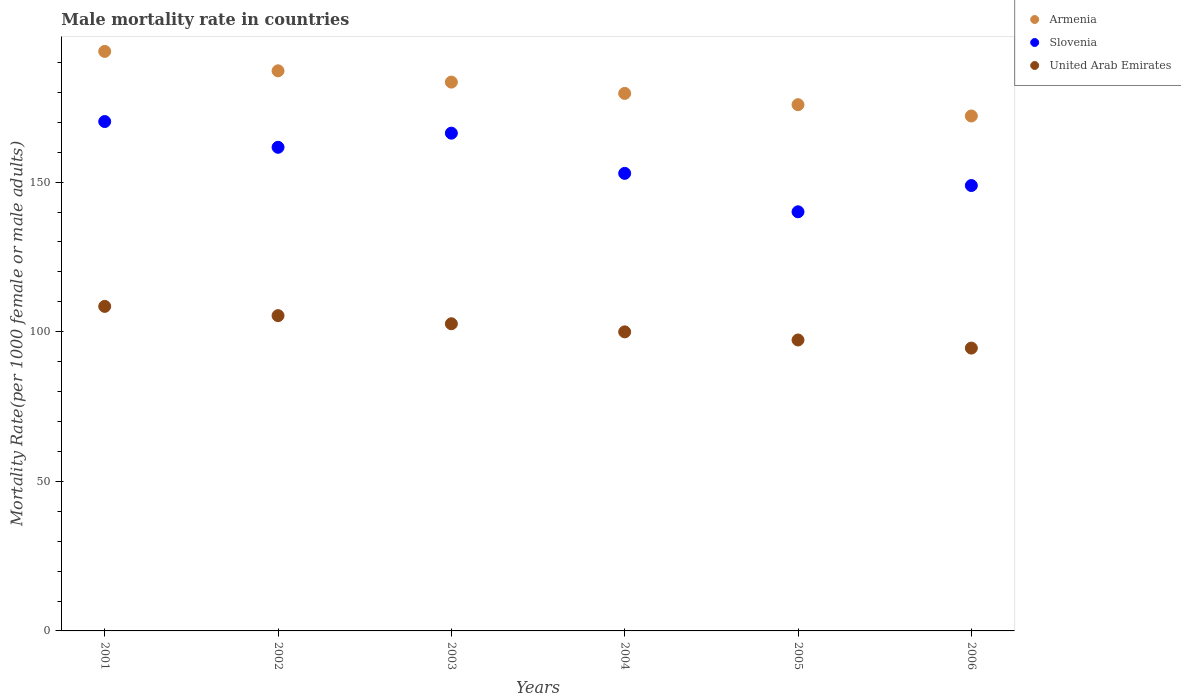How many different coloured dotlines are there?
Your answer should be compact. 3. What is the male mortality rate in Armenia in 2001?
Offer a very short reply. 193.7. Across all years, what is the maximum male mortality rate in Armenia?
Provide a succinct answer. 193.7. Across all years, what is the minimum male mortality rate in United Arab Emirates?
Your response must be concise. 94.53. In which year was the male mortality rate in United Arab Emirates maximum?
Provide a short and direct response. 2001. What is the total male mortality rate in Slovenia in the graph?
Your answer should be compact. 940.16. What is the difference between the male mortality rate in United Arab Emirates in 2002 and that in 2004?
Your answer should be compact. 5.42. What is the difference between the male mortality rate in United Arab Emirates in 2004 and the male mortality rate in Slovenia in 2002?
Your answer should be compact. -61.69. What is the average male mortality rate in Armenia per year?
Make the answer very short. 182. In the year 2005, what is the difference between the male mortality rate in Slovenia and male mortality rate in United Arab Emirates?
Your answer should be very brief. 42.84. What is the ratio of the male mortality rate in Slovenia in 2002 to that in 2003?
Give a very brief answer. 0.97. What is the difference between the highest and the second highest male mortality rate in United Arab Emirates?
Keep it short and to the point. 3.09. What is the difference between the highest and the lowest male mortality rate in Slovenia?
Keep it short and to the point. 30.17. In how many years, is the male mortality rate in Slovenia greater than the average male mortality rate in Slovenia taken over all years?
Provide a succinct answer. 3. Is the sum of the male mortality rate in Armenia in 2001 and 2005 greater than the maximum male mortality rate in United Arab Emirates across all years?
Provide a short and direct response. Yes. Is it the case that in every year, the sum of the male mortality rate in Slovenia and male mortality rate in Armenia  is greater than the male mortality rate in United Arab Emirates?
Provide a succinct answer. Yes. Does the male mortality rate in Armenia monotonically increase over the years?
Make the answer very short. No. Is the male mortality rate in Armenia strictly greater than the male mortality rate in Slovenia over the years?
Offer a very short reply. Yes. How many years are there in the graph?
Offer a very short reply. 6. What is the difference between two consecutive major ticks on the Y-axis?
Your answer should be very brief. 50. Are the values on the major ticks of Y-axis written in scientific E-notation?
Give a very brief answer. No. Does the graph contain grids?
Your answer should be compact. No. How many legend labels are there?
Your answer should be very brief. 3. What is the title of the graph?
Offer a very short reply. Male mortality rate in countries. Does "Papua New Guinea" appear as one of the legend labels in the graph?
Give a very brief answer. No. What is the label or title of the Y-axis?
Offer a very short reply. Mortality Rate(per 1000 female or male adults). What is the Mortality Rate(per 1000 female or male adults) in Armenia in 2001?
Provide a succinct answer. 193.7. What is the Mortality Rate(per 1000 female or male adults) of Slovenia in 2001?
Your answer should be very brief. 170.25. What is the Mortality Rate(per 1000 female or male adults) of United Arab Emirates in 2001?
Make the answer very short. 108.47. What is the Mortality Rate(per 1000 female or male adults) of Armenia in 2002?
Your answer should be very brief. 187.21. What is the Mortality Rate(per 1000 female or male adults) of Slovenia in 2002?
Make the answer very short. 161.65. What is the Mortality Rate(per 1000 female or male adults) of United Arab Emirates in 2002?
Your answer should be very brief. 105.38. What is the Mortality Rate(per 1000 female or male adults) of Armenia in 2003?
Provide a succinct answer. 183.43. What is the Mortality Rate(per 1000 female or male adults) in Slovenia in 2003?
Offer a very short reply. 166.37. What is the Mortality Rate(per 1000 female or male adults) of United Arab Emirates in 2003?
Ensure brevity in your answer.  102.67. What is the Mortality Rate(per 1000 female or male adults) of Armenia in 2004?
Ensure brevity in your answer.  179.66. What is the Mortality Rate(per 1000 female or male adults) of Slovenia in 2004?
Provide a short and direct response. 152.93. What is the Mortality Rate(per 1000 female or male adults) of United Arab Emirates in 2004?
Offer a terse response. 99.96. What is the Mortality Rate(per 1000 female or male adults) in Armenia in 2005?
Give a very brief answer. 175.89. What is the Mortality Rate(per 1000 female or male adults) of Slovenia in 2005?
Offer a terse response. 140.09. What is the Mortality Rate(per 1000 female or male adults) of United Arab Emirates in 2005?
Keep it short and to the point. 97.25. What is the Mortality Rate(per 1000 female or male adults) in Armenia in 2006?
Provide a short and direct response. 172.11. What is the Mortality Rate(per 1000 female or male adults) in Slovenia in 2006?
Ensure brevity in your answer.  148.87. What is the Mortality Rate(per 1000 female or male adults) in United Arab Emirates in 2006?
Ensure brevity in your answer.  94.53. Across all years, what is the maximum Mortality Rate(per 1000 female or male adults) of Armenia?
Offer a very short reply. 193.7. Across all years, what is the maximum Mortality Rate(per 1000 female or male adults) in Slovenia?
Offer a terse response. 170.25. Across all years, what is the maximum Mortality Rate(per 1000 female or male adults) in United Arab Emirates?
Give a very brief answer. 108.47. Across all years, what is the minimum Mortality Rate(per 1000 female or male adults) of Armenia?
Your answer should be compact. 172.11. Across all years, what is the minimum Mortality Rate(per 1000 female or male adults) of Slovenia?
Ensure brevity in your answer.  140.09. Across all years, what is the minimum Mortality Rate(per 1000 female or male adults) in United Arab Emirates?
Keep it short and to the point. 94.53. What is the total Mortality Rate(per 1000 female or male adults) in Armenia in the graph?
Offer a terse response. 1092. What is the total Mortality Rate(per 1000 female or male adults) in Slovenia in the graph?
Make the answer very short. 940.16. What is the total Mortality Rate(per 1000 female or male adults) in United Arab Emirates in the graph?
Provide a short and direct response. 608.25. What is the difference between the Mortality Rate(per 1000 female or male adults) in Armenia in 2001 and that in 2002?
Offer a very short reply. 6.49. What is the difference between the Mortality Rate(per 1000 female or male adults) of Slovenia in 2001 and that in 2002?
Ensure brevity in your answer.  8.6. What is the difference between the Mortality Rate(per 1000 female or male adults) in United Arab Emirates in 2001 and that in 2002?
Provide a succinct answer. 3.1. What is the difference between the Mortality Rate(per 1000 female or male adults) of Armenia in 2001 and that in 2003?
Give a very brief answer. 10.26. What is the difference between the Mortality Rate(per 1000 female or male adults) of Slovenia in 2001 and that in 2003?
Offer a very short reply. 3.88. What is the difference between the Mortality Rate(per 1000 female or male adults) of United Arab Emirates in 2001 and that in 2003?
Offer a very short reply. 5.81. What is the difference between the Mortality Rate(per 1000 female or male adults) of Armenia in 2001 and that in 2004?
Offer a very short reply. 14.04. What is the difference between the Mortality Rate(per 1000 female or male adults) of Slovenia in 2001 and that in 2004?
Your answer should be very brief. 17.32. What is the difference between the Mortality Rate(per 1000 female or male adults) in United Arab Emirates in 2001 and that in 2004?
Ensure brevity in your answer.  8.52. What is the difference between the Mortality Rate(per 1000 female or male adults) in Armenia in 2001 and that in 2005?
Make the answer very short. 17.81. What is the difference between the Mortality Rate(per 1000 female or male adults) of Slovenia in 2001 and that in 2005?
Make the answer very short. 30.17. What is the difference between the Mortality Rate(per 1000 female or male adults) of United Arab Emirates in 2001 and that in 2005?
Provide a succinct answer. 11.23. What is the difference between the Mortality Rate(per 1000 female or male adults) in Armenia in 2001 and that in 2006?
Your answer should be very brief. 21.58. What is the difference between the Mortality Rate(per 1000 female or male adults) in Slovenia in 2001 and that in 2006?
Offer a terse response. 21.38. What is the difference between the Mortality Rate(per 1000 female or male adults) in United Arab Emirates in 2001 and that in 2006?
Provide a succinct answer. 13.94. What is the difference between the Mortality Rate(per 1000 female or male adults) of Armenia in 2002 and that in 2003?
Offer a terse response. 3.77. What is the difference between the Mortality Rate(per 1000 female or male adults) in Slovenia in 2002 and that in 2003?
Your answer should be compact. -4.72. What is the difference between the Mortality Rate(per 1000 female or male adults) of United Arab Emirates in 2002 and that in 2003?
Give a very brief answer. 2.71. What is the difference between the Mortality Rate(per 1000 female or male adults) in Armenia in 2002 and that in 2004?
Keep it short and to the point. 7.55. What is the difference between the Mortality Rate(per 1000 female or male adults) in Slovenia in 2002 and that in 2004?
Offer a very short reply. 8.72. What is the difference between the Mortality Rate(per 1000 female or male adults) of United Arab Emirates in 2002 and that in 2004?
Provide a succinct answer. 5.42. What is the difference between the Mortality Rate(per 1000 female or male adults) of Armenia in 2002 and that in 2005?
Your answer should be compact. 11.32. What is the difference between the Mortality Rate(per 1000 female or male adults) in Slovenia in 2002 and that in 2005?
Give a very brief answer. 21.56. What is the difference between the Mortality Rate(per 1000 female or male adults) in United Arab Emirates in 2002 and that in 2005?
Offer a terse response. 8.13. What is the difference between the Mortality Rate(per 1000 female or male adults) of Armenia in 2002 and that in 2006?
Your answer should be very brief. 15.09. What is the difference between the Mortality Rate(per 1000 female or male adults) of Slovenia in 2002 and that in 2006?
Provide a short and direct response. 12.78. What is the difference between the Mortality Rate(per 1000 female or male adults) of United Arab Emirates in 2002 and that in 2006?
Offer a terse response. 10.84. What is the difference between the Mortality Rate(per 1000 female or male adults) in Armenia in 2003 and that in 2004?
Your answer should be compact. 3.77. What is the difference between the Mortality Rate(per 1000 female or male adults) of Slovenia in 2003 and that in 2004?
Keep it short and to the point. 13.44. What is the difference between the Mortality Rate(per 1000 female or male adults) in United Arab Emirates in 2003 and that in 2004?
Provide a short and direct response. 2.71. What is the difference between the Mortality Rate(per 1000 female or male adults) in Armenia in 2003 and that in 2005?
Offer a very short reply. 7.55. What is the difference between the Mortality Rate(per 1000 female or male adults) in Slovenia in 2003 and that in 2005?
Your answer should be very brief. 26.29. What is the difference between the Mortality Rate(per 1000 female or male adults) in United Arab Emirates in 2003 and that in 2005?
Your answer should be very brief. 5.42. What is the difference between the Mortality Rate(per 1000 female or male adults) in Armenia in 2003 and that in 2006?
Make the answer very short. 11.32. What is the difference between the Mortality Rate(per 1000 female or male adults) in United Arab Emirates in 2003 and that in 2006?
Your answer should be compact. 8.13. What is the difference between the Mortality Rate(per 1000 female or male adults) in Armenia in 2004 and that in 2005?
Your answer should be compact. 3.77. What is the difference between the Mortality Rate(per 1000 female or male adults) of Slovenia in 2004 and that in 2005?
Make the answer very short. 12.85. What is the difference between the Mortality Rate(per 1000 female or male adults) of United Arab Emirates in 2004 and that in 2005?
Give a very brief answer. 2.71. What is the difference between the Mortality Rate(per 1000 female or male adults) in Armenia in 2004 and that in 2006?
Ensure brevity in your answer.  7.55. What is the difference between the Mortality Rate(per 1000 female or male adults) of Slovenia in 2004 and that in 2006?
Provide a short and direct response. 4.06. What is the difference between the Mortality Rate(per 1000 female or male adults) in United Arab Emirates in 2004 and that in 2006?
Your response must be concise. 5.42. What is the difference between the Mortality Rate(per 1000 female or male adults) of Armenia in 2005 and that in 2006?
Give a very brief answer. 3.77. What is the difference between the Mortality Rate(per 1000 female or male adults) in Slovenia in 2005 and that in 2006?
Provide a succinct answer. -8.79. What is the difference between the Mortality Rate(per 1000 female or male adults) of United Arab Emirates in 2005 and that in 2006?
Give a very brief answer. 2.71. What is the difference between the Mortality Rate(per 1000 female or male adults) of Armenia in 2001 and the Mortality Rate(per 1000 female or male adults) of Slovenia in 2002?
Your answer should be very brief. 32.05. What is the difference between the Mortality Rate(per 1000 female or male adults) in Armenia in 2001 and the Mortality Rate(per 1000 female or male adults) in United Arab Emirates in 2002?
Provide a short and direct response. 88.32. What is the difference between the Mortality Rate(per 1000 female or male adults) of Slovenia in 2001 and the Mortality Rate(per 1000 female or male adults) of United Arab Emirates in 2002?
Provide a short and direct response. 64.88. What is the difference between the Mortality Rate(per 1000 female or male adults) of Armenia in 2001 and the Mortality Rate(per 1000 female or male adults) of Slovenia in 2003?
Make the answer very short. 27.32. What is the difference between the Mortality Rate(per 1000 female or male adults) in Armenia in 2001 and the Mortality Rate(per 1000 female or male adults) in United Arab Emirates in 2003?
Your answer should be compact. 91.03. What is the difference between the Mortality Rate(per 1000 female or male adults) in Slovenia in 2001 and the Mortality Rate(per 1000 female or male adults) in United Arab Emirates in 2003?
Give a very brief answer. 67.59. What is the difference between the Mortality Rate(per 1000 female or male adults) in Armenia in 2001 and the Mortality Rate(per 1000 female or male adults) in Slovenia in 2004?
Offer a very short reply. 40.76. What is the difference between the Mortality Rate(per 1000 female or male adults) of Armenia in 2001 and the Mortality Rate(per 1000 female or male adults) of United Arab Emirates in 2004?
Keep it short and to the point. 93.74. What is the difference between the Mortality Rate(per 1000 female or male adults) in Slovenia in 2001 and the Mortality Rate(per 1000 female or male adults) in United Arab Emirates in 2004?
Make the answer very short. 70.3. What is the difference between the Mortality Rate(per 1000 female or male adults) in Armenia in 2001 and the Mortality Rate(per 1000 female or male adults) in Slovenia in 2005?
Make the answer very short. 53.61. What is the difference between the Mortality Rate(per 1000 female or male adults) of Armenia in 2001 and the Mortality Rate(per 1000 female or male adults) of United Arab Emirates in 2005?
Ensure brevity in your answer.  96.45. What is the difference between the Mortality Rate(per 1000 female or male adults) of Slovenia in 2001 and the Mortality Rate(per 1000 female or male adults) of United Arab Emirates in 2005?
Keep it short and to the point. 73.01. What is the difference between the Mortality Rate(per 1000 female or male adults) in Armenia in 2001 and the Mortality Rate(per 1000 female or male adults) in Slovenia in 2006?
Offer a very short reply. 44.83. What is the difference between the Mortality Rate(per 1000 female or male adults) of Armenia in 2001 and the Mortality Rate(per 1000 female or male adults) of United Arab Emirates in 2006?
Provide a short and direct response. 99.16. What is the difference between the Mortality Rate(per 1000 female or male adults) of Slovenia in 2001 and the Mortality Rate(per 1000 female or male adults) of United Arab Emirates in 2006?
Your answer should be compact. 75.72. What is the difference between the Mortality Rate(per 1000 female or male adults) in Armenia in 2002 and the Mortality Rate(per 1000 female or male adults) in Slovenia in 2003?
Provide a short and direct response. 20.84. What is the difference between the Mortality Rate(per 1000 female or male adults) in Armenia in 2002 and the Mortality Rate(per 1000 female or male adults) in United Arab Emirates in 2003?
Your answer should be very brief. 84.54. What is the difference between the Mortality Rate(per 1000 female or male adults) of Slovenia in 2002 and the Mortality Rate(per 1000 female or male adults) of United Arab Emirates in 2003?
Your answer should be very brief. 58.98. What is the difference between the Mortality Rate(per 1000 female or male adults) in Armenia in 2002 and the Mortality Rate(per 1000 female or male adults) in Slovenia in 2004?
Offer a very short reply. 34.27. What is the difference between the Mortality Rate(per 1000 female or male adults) in Armenia in 2002 and the Mortality Rate(per 1000 female or male adults) in United Arab Emirates in 2004?
Offer a very short reply. 87.25. What is the difference between the Mortality Rate(per 1000 female or male adults) of Slovenia in 2002 and the Mortality Rate(per 1000 female or male adults) of United Arab Emirates in 2004?
Ensure brevity in your answer.  61.69. What is the difference between the Mortality Rate(per 1000 female or male adults) of Armenia in 2002 and the Mortality Rate(per 1000 female or male adults) of Slovenia in 2005?
Give a very brief answer. 47.12. What is the difference between the Mortality Rate(per 1000 female or male adults) in Armenia in 2002 and the Mortality Rate(per 1000 female or male adults) in United Arab Emirates in 2005?
Keep it short and to the point. 89.96. What is the difference between the Mortality Rate(per 1000 female or male adults) in Slovenia in 2002 and the Mortality Rate(per 1000 female or male adults) in United Arab Emirates in 2005?
Your answer should be compact. 64.41. What is the difference between the Mortality Rate(per 1000 female or male adults) in Armenia in 2002 and the Mortality Rate(per 1000 female or male adults) in Slovenia in 2006?
Make the answer very short. 38.34. What is the difference between the Mortality Rate(per 1000 female or male adults) of Armenia in 2002 and the Mortality Rate(per 1000 female or male adults) of United Arab Emirates in 2006?
Your answer should be very brief. 92.67. What is the difference between the Mortality Rate(per 1000 female or male adults) of Slovenia in 2002 and the Mortality Rate(per 1000 female or male adults) of United Arab Emirates in 2006?
Your response must be concise. 67.12. What is the difference between the Mortality Rate(per 1000 female or male adults) in Armenia in 2003 and the Mortality Rate(per 1000 female or male adults) in Slovenia in 2004?
Offer a terse response. 30.5. What is the difference between the Mortality Rate(per 1000 female or male adults) in Armenia in 2003 and the Mortality Rate(per 1000 female or male adults) in United Arab Emirates in 2004?
Make the answer very short. 83.48. What is the difference between the Mortality Rate(per 1000 female or male adults) of Slovenia in 2003 and the Mortality Rate(per 1000 female or male adults) of United Arab Emirates in 2004?
Ensure brevity in your answer.  66.42. What is the difference between the Mortality Rate(per 1000 female or male adults) in Armenia in 2003 and the Mortality Rate(per 1000 female or male adults) in Slovenia in 2005?
Offer a very short reply. 43.35. What is the difference between the Mortality Rate(per 1000 female or male adults) in Armenia in 2003 and the Mortality Rate(per 1000 female or male adults) in United Arab Emirates in 2005?
Make the answer very short. 86.19. What is the difference between the Mortality Rate(per 1000 female or male adults) in Slovenia in 2003 and the Mortality Rate(per 1000 female or male adults) in United Arab Emirates in 2005?
Ensure brevity in your answer.  69.13. What is the difference between the Mortality Rate(per 1000 female or male adults) of Armenia in 2003 and the Mortality Rate(per 1000 female or male adults) of Slovenia in 2006?
Provide a short and direct response. 34.56. What is the difference between the Mortality Rate(per 1000 female or male adults) of Armenia in 2003 and the Mortality Rate(per 1000 female or male adults) of United Arab Emirates in 2006?
Offer a terse response. 88.9. What is the difference between the Mortality Rate(per 1000 female or male adults) in Slovenia in 2003 and the Mortality Rate(per 1000 female or male adults) in United Arab Emirates in 2006?
Give a very brief answer. 71.84. What is the difference between the Mortality Rate(per 1000 female or male adults) of Armenia in 2004 and the Mortality Rate(per 1000 female or male adults) of Slovenia in 2005?
Ensure brevity in your answer.  39.57. What is the difference between the Mortality Rate(per 1000 female or male adults) of Armenia in 2004 and the Mortality Rate(per 1000 female or male adults) of United Arab Emirates in 2005?
Provide a short and direct response. 82.42. What is the difference between the Mortality Rate(per 1000 female or male adults) in Slovenia in 2004 and the Mortality Rate(per 1000 female or male adults) in United Arab Emirates in 2005?
Your response must be concise. 55.69. What is the difference between the Mortality Rate(per 1000 female or male adults) of Armenia in 2004 and the Mortality Rate(per 1000 female or male adults) of Slovenia in 2006?
Keep it short and to the point. 30.79. What is the difference between the Mortality Rate(per 1000 female or male adults) in Armenia in 2004 and the Mortality Rate(per 1000 female or male adults) in United Arab Emirates in 2006?
Ensure brevity in your answer.  85.13. What is the difference between the Mortality Rate(per 1000 female or male adults) of Slovenia in 2004 and the Mortality Rate(per 1000 female or male adults) of United Arab Emirates in 2006?
Make the answer very short. 58.4. What is the difference between the Mortality Rate(per 1000 female or male adults) in Armenia in 2005 and the Mortality Rate(per 1000 female or male adults) in Slovenia in 2006?
Your response must be concise. 27.02. What is the difference between the Mortality Rate(per 1000 female or male adults) in Armenia in 2005 and the Mortality Rate(per 1000 female or male adults) in United Arab Emirates in 2006?
Provide a short and direct response. 81.35. What is the difference between the Mortality Rate(per 1000 female or male adults) of Slovenia in 2005 and the Mortality Rate(per 1000 female or male adults) of United Arab Emirates in 2006?
Provide a short and direct response. 45.55. What is the average Mortality Rate(per 1000 female or male adults) of Armenia per year?
Provide a succinct answer. 182. What is the average Mortality Rate(per 1000 female or male adults) of Slovenia per year?
Your answer should be very brief. 156.69. What is the average Mortality Rate(per 1000 female or male adults) in United Arab Emirates per year?
Your answer should be very brief. 101.38. In the year 2001, what is the difference between the Mortality Rate(per 1000 female or male adults) in Armenia and Mortality Rate(per 1000 female or male adults) in Slovenia?
Offer a terse response. 23.44. In the year 2001, what is the difference between the Mortality Rate(per 1000 female or male adults) in Armenia and Mortality Rate(per 1000 female or male adults) in United Arab Emirates?
Provide a succinct answer. 85.22. In the year 2001, what is the difference between the Mortality Rate(per 1000 female or male adults) of Slovenia and Mortality Rate(per 1000 female or male adults) of United Arab Emirates?
Your answer should be compact. 61.78. In the year 2002, what is the difference between the Mortality Rate(per 1000 female or male adults) in Armenia and Mortality Rate(per 1000 female or male adults) in Slovenia?
Provide a succinct answer. 25.56. In the year 2002, what is the difference between the Mortality Rate(per 1000 female or male adults) of Armenia and Mortality Rate(per 1000 female or male adults) of United Arab Emirates?
Your answer should be compact. 81.83. In the year 2002, what is the difference between the Mortality Rate(per 1000 female or male adults) in Slovenia and Mortality Rate(per 1000 female or male adults) in United Arab Emirates?
Give a very brief answer. 56.27. In the year 2003, what is the difference between the Mortality Rate(per 1000 female or male adults) of Armenia and Mortality Rate(per 1000 female or male adults) of Slovenia?
Ensure brevity in your answer.  17.06. In the year 2003, what is the difference between the Mortality Rate(per 1000 female or male adults) of Armenia and Mortality Rate(per 1000 female or male adults) of United Arab Emirates?
Make the answer very short. 80.77. In the year 2003, what is the difference between the Mortality Rate(per 1000 female or male adults) of Slovenia and Mortality Rate(per 1000 female or male adults) of United Arab Emirates?
Keep it short and to the point. 63.7. In the year 2004, what is the difference between the Mortality Rate(per 1000 female or male adults) of Armenia and Mortality Rate(per 1000 female or male adults) of Slovenia?
Your answer should be compact. 26.73. In the year 2004, what is the difference between the Mortality Rate(per 1000 female or male adults) of Armenia and Mortality Rate(per 1000 female or male adults) of United Arab Emirates?
Ensure brevity in your answer.  79.7. In the year 2004, what is the difference between the Mortality Rate(per 1000 female or male adults) in Slovenia and Mortality Rate(per 1000 female or male adults) in United Arab Emirates?
Make the answer very short. 52.98. In the year 2005, what is the difference between the Mortality Rate(per 1000 female or male adults) in Armenia and Mortality Rate(per 1000 female or male adults) in Slovenia?
Your answer should be very brief. 35.8. In the year 2005, what is the difference between the Mortality Rate(per 1000 female or male adults) in Armenia and Mortality Rate(per 1000 female or male adults) in United Arab Emirates?
Keep it short and to the point. 78.64. In the year 2005, what is the difference between the Mortality Rate(per 1000 female or male adults) of Slovenia and Mortality Rate(per 1000 female or male adults) of United Arab Emirates?
Ensure brevity in your answer.  42.84. In the year 2006, what is the difference between the Mortality Rate(per 1000 female or male adults) in Armenia and Mortality Rate(per 1000 female or male adults) in Slovenia?
Ensure brevity in your answer.  23.24. In the year 2006, what is the difference between the Mortality Rate(per 1000 female or male adults) of Armenia and Mortality Rate(per 1000 female or male adults) of United Arab Emirates?
Give a very brief answer. 77.58. In the year 2006, what is the difference between the Mortality Rate(per 1000 female or male adults) of Slovenia and Mortality Rate(per 1000 female or male adults) of United Arab Emirates?
Offer a very short reply. 54.34. What is the ratio of the Mortality Rate(per 1000 female or male adults) in Armenia in 2001 to that in 2002?
Provide a succinct answer. 1.03. What is the ratio of the Mortality Rate(per 1000 female or male adults) in Slovenia in 2001 to that in 2002?
Ensure brevity in your answer.  1.05. What is the ratio of the Mortality Rate(per 1000 female or male adults) of United Arab Emirates in 2001 to that in 2002?
Provide a short and direct response. 1.03. What is the ratio of the Mortality Rate(per 1000 female or male adults) in Armenia in 2001 to that in 2003?
Offer a terse response. 1.06. What is the ratio of the Mortality Rate(per 1000 female or male adults) of Slovenia in 2001 to that in 2003?
Keep it short and to the point. 1.02. What is the ratio of the Mortality Rate(per 1000 female or male adults) in United Arab Emirates in 2001 to that in 2003?
Make the answer very short. 1.06. What is the ratio of the Mortality Rate(per 1000 female or male adults) of Armenia in 2001 to that in 2004?
Your response must be concise. 1.08. What is the ratio of the Mortality Rate(per 1000 female or male adults) of Slovenia in 2001 to that in 2004?
Your answer should be very brief. 1.11. What is the ratio of the Mortality Rate(per 1000 female or male adults) in United Arab Emirates in 2001 to that in 2004?
Ensure brevity in your answer.  1.09. What is the ratio of the Mortality Rate(per 1000 female or male adults) of Armenia in 2001 to that in 2005?
Make the answer very short. 1.1. What is the ratio of the Mortality Rate(per 1000 female or male adults) of Slovenia in 2001 to that in 2005?
Provide a short and direct response. 1.22. What is the ratio of the Mortality Rate(per 1000 female or male adults) in United Arab Emirates in 2001 to that in 2005?
Provide a short and direct response. 1.12. What is the ratio of the Mortality Rate(per 1000 female or male adults) in Armenia in 2001 to that in 2006?
Make the answer very short. 1.13. What is the ratio of the Mortality Rate(per 1000 female or male adults) in Slovenia in 2001 to that in 2006?
Provide a succinct answer. 1.14. What is the ratio of the Mortality Rate(per 1000 female or male adults) of United Arab Emirates in 2001 to that in 2006?
Keep it short and to the point. 1.15. What is the ratio of the Mortality Rate(per 1000 female or male adults) of Armenia in 2002 to that in 2003?
Make the answer very short. 1.02. What is the ratio of the Mortality Rate(per 1000 female or male adults) in Slovenia in 2002 to that in 2003?
Keep it short and to the point. 0.97. What is the ratio of the Mortality Rate(per 1000 female or male adults) in United Arab Emirates in 2002 to that in 2003?
Provide a succinct answer. 1.03. What is the ratio of the Mortality Rate(per 1000 female or male adults) of Armenia in 2002 to that in 2004?
Make the answer very short. 1.04. What is the ratio of the Mortality Rate(per 1000 female or male adults) in Slovenia in 2002 to that in 2004?
Ensure brevity in your answer.  1.06. What is the ratio of the Mortality Rate(per 1000 female or male adults) in United Arab Emirates in 2002 to that in 2004?
Offer a terse response. 1.05. What is the ratio of the Mortality Rate(per 1000 female or male adults) in Armenia in 2002 to that in 2005?
Offer a terse response. 1.06. What is the ratio of the Mortality Rate(per 1000 female or male adults) in Slovenia in 2002 to that in 2005?
Your answer should be compact. 1.15. What is the ratio of the Mortality Rate(per 1000 female or male adults) in United Arab Emirates in 2002 to that in 2005?
Your answer should be very brief. 1.08. What is the ratio of the Mortality Rate(per 1000 female or male adults) in Armenia in 2002 to that in 2006?
Provide a succinct answer. 1.09. What is the ratio of the Mortality Rate(per 1000 female or male adults) in Slovenia in 2002 to that in 2006?
Keep it short and to the point. 1.09. What is the ratio of the Mortality Rate(per 1000 female or male adults) in United Arab Emirates in 2002 to that in 2006?
Your answer should be very brief. 1.11. What is the ratio of the Mortality Rate(per 1000 female or male adults) of Slovenia in 2003 to that in 2004?
Provide a succinct answer. 1.09. What is the ratio of the Mortality Rate(per 1000 female or male adults) in United Arab Emirates in 2003 to that in 2004?
Make the answer very short. 1.03. What is the ratio of the Mortality Rate(per 1000 female or male adults) in Armenia in 2003 to that in 2005?
Make the answer very short. 1.04. What is the ratio of the Mortality Rate(per 1000 female or male adults) of Slovenia in 2003 to that in 2005?
Your answer should be compact. 1.19. What is the ratio of the Mortality Rate(per 1000 female or male adults) of United Arab Emirates in 2003 to that in 2005?
Your answer should be very brief. 1.06. What is the ratio of the Mortality Rate(per 1000 female or male adults) in Armenia in 2003 to that in 2006?
Your answer should be compact. 1.07. What is the ratio of the Mortality Rate(per 1000 female or male adults) in Slovenia in 2003 to that in 2006?
Your answer should be compact. 1.12. What is the ratio of the Mortality Rate(per 1000 female or male adults) of United Arab Emirates in 2003 to that in 2006?
Your answer should be compact. 1.09. What is the ratio of the Mortality Rate(per 1000 female or male adults) of Armenia in 2004 to that in 2005?
Provide a short and direct response. 1.02. What is the ratio of the Mortality Rate(per 1000 female or male adults) of Slovenia in 2004 to that in 2005?
Give a very brief answer. 1.09. What is the ratio of the Mortality Rate(per 1000 female or male adults) of United Arab Emirates in 2004 to that in 2005?
Ensure brevity in your answer.  1.03. What is the ratio of the Mortality Rate(per 1000 female or male adults) of Armenia in 2004 to that in 2006?
Your answer should be compact. 1.04. What is the ratio of the Mortality Rate(per 1000 female or male adults) in Slovenia in 2004 to that in 2006?
Provide a succinct answer. 1.03. What is the ratio of the Mortality Rate(per 1000 female or male adults) of United Arab Emirates in 2004 to that in 2006?
Your answer should be very brief. 1.06. What is the ratio of the Mortality Rate(per 1000 female or male adults) of Armenia in 2005 to that in 2006?
Provide a short and direct response. 1.02. What is the ratio of the Mortality Rate(per 1000 female or male adults) in Slovenia in 2005 to that in 2006?
Provide a short and direct response. 0.94. What is the ratio of the Mortality Rate(per 1000 female or male adults) of United Arab Emirates in 2005 to that in 2006?
Provide a succinct answer. 1.03. What is the difference between the highest and the second highest Mortality Rate(per 1000 female or male adults) of Armenia?
Provide a short and direct response. 6.49. What is the difference between the highest and the second highest Mortality Rate(per 1000 female or male adults) in Slovenia?
Give a very brief answer. 3.88. What is the difference between the highest and the second highest Mortality Rate(per 1000 female or male adults) of United Arab Emirates?
Give a very brief answer. 3.1. What is the difference between the highest and the lowest Mortality Rate(per 1000 female or male adults) in Armenia?
Make the answer very short. 21.58. What is the difference between the highest and the lowest Mortality Rate(per 1000 female or male adults) in Slovenia?
Provide a short and direct response. 30.17. What is the difference between the highest and the lowest Mortality Rate(per 1000 female or male adults) of United Arab Emirates?
Provide a short and direct response. 13.94. 